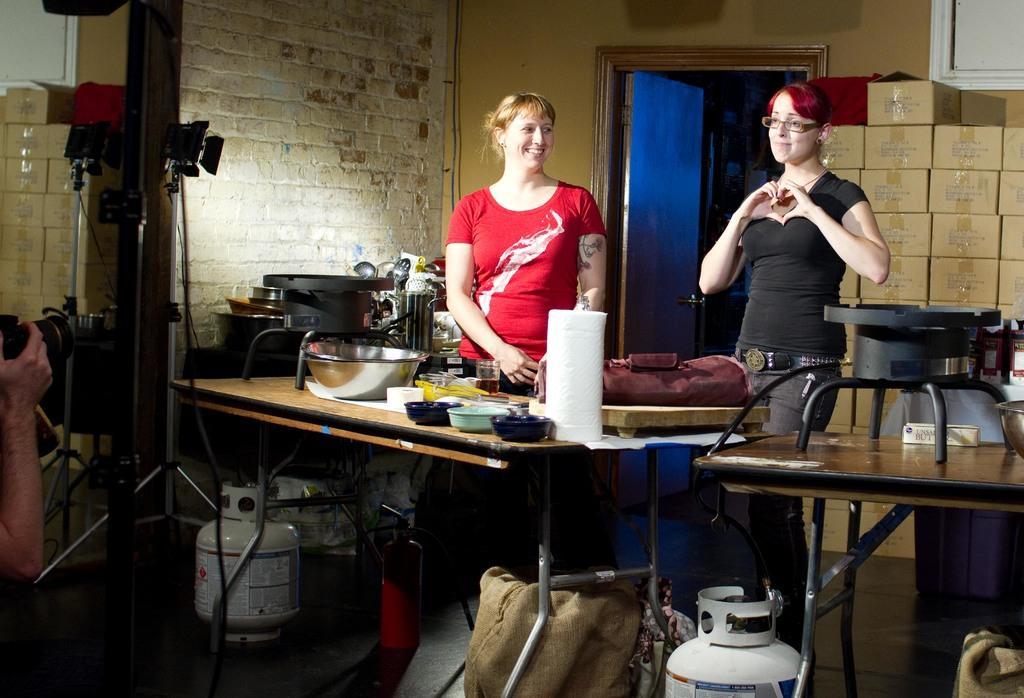Describe this image in one or two sentences. In this image two women are standing. On the table there is a bowl,glass,stove,spoon stand. On the floor there is emergency gas cylinder. At the back side there is door and a wall. 